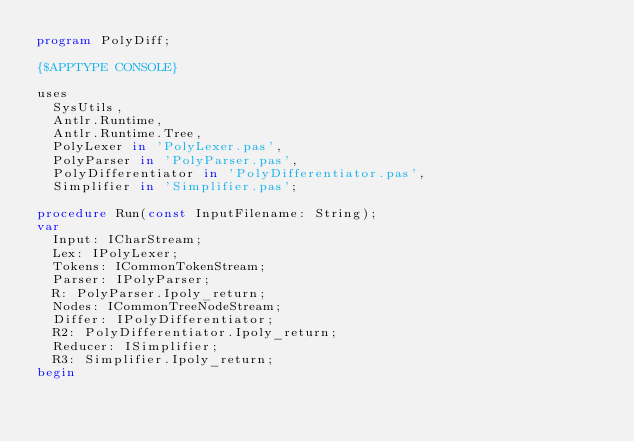<code> <loc_0><loc_0><loc_500><loc_500><_Pascal_>program PolyDiff;

{$APPTYPE CONSOLE}

uses
  SysUtils,
  Antlr.Runtime,
  Antlr.Runtime.Tree,
  PolyLexer in 'PolyLexer.pas',
  PolyParser in 'PolyParser.pas',
  PolyDifferentiator in 'PolyDifferentiator.pas',
  Simplifier in 'Simplifier.pas';

procedure Run(const InputFilename: String);
var
  Input: ICharStream;
  Lex: IPolyLexer;
  Tokens: ICommonTokenStream;
  Parser: IPolyParser;
  R: PolyParser.Ipoly_return;
  Nodes: ICommonTreeNodeStream;
  Differ: IPolyDifferentiator;
  R2: PolyDifferentiator.Ipoly_return;
  Reducer: ISimplifier;
  R3: Simplifier.Ipoly_return;
begin</code> 